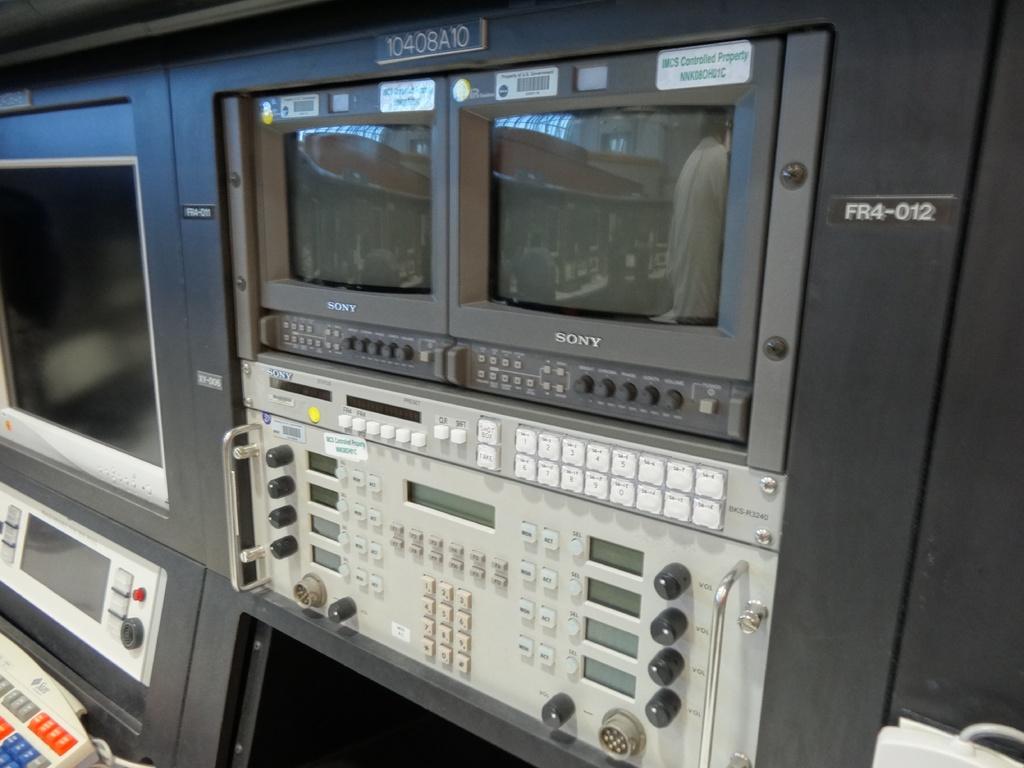What is the machine model number?
Keep it short and to the point. Fr4-012. 